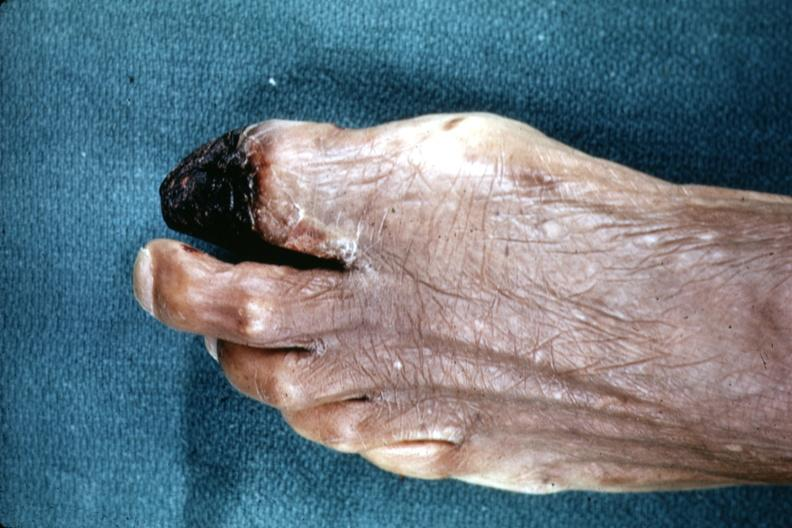what does this image show?
Answer the question using a single word or phrase. Excellent example of gangrene of great toe 